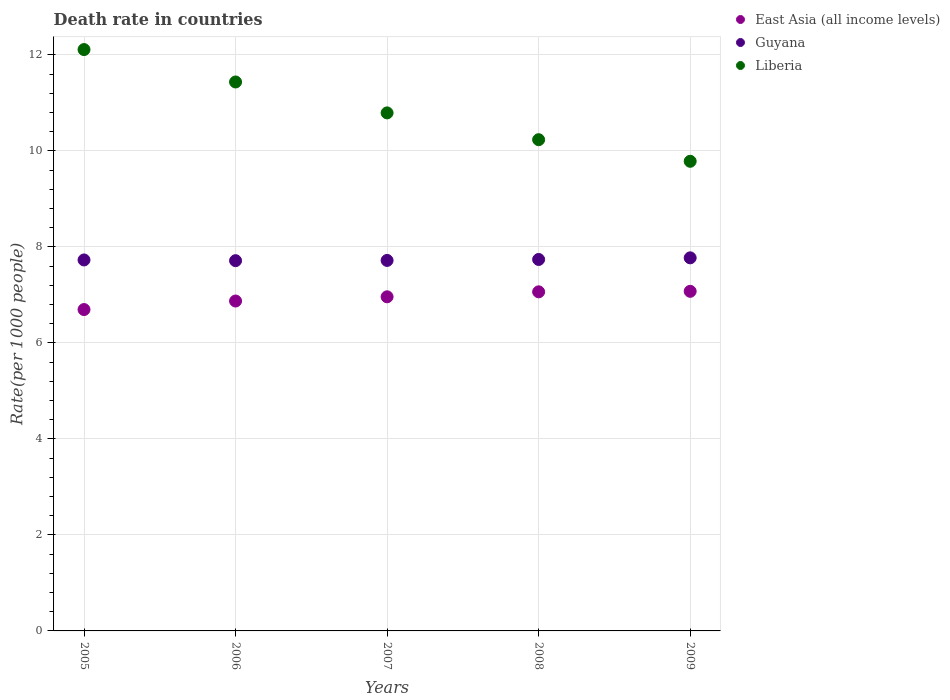How many different coloured dotlines are there?
Your answer should be very brief. 3. Is the number of dotlines equal to the number of legend labels?
Offer a very short reply. Yes. What is the death rate in Guyana in 2007?
Your response must be concise. 7.72. Across all years, what is the maximum death rate in Guyana?
Offer a terse response. 7.77. Across all years, what is the minimum death rate in Guyana?
Keep it short and to the point. 7.71. In which year was the death rate in Liberia maximum?
Offer a terse response. 2005. In which year was the death rate in Liberia minimum?
Your answer should be compact. 2009. What is the total death rate in East Asia (all income levels) in the graph?
Offer a very short reply. 34.66. What is the difference between the death rate in East Asia (all income levels) in 2006 and that in 2009?
Ensure brevity in your answer.  -0.2. What is the difference between the death rate in Liberia in 2007 and the death rate in East Asia (all income levels) in 2009?
Your answer should be very brief. 3.72. What is the average death rate in East Asia (all income levels) per year?
Your answer should be very brief. 6.93. In the year 2005, what is the difference between the death rate in Liberia and death rate in East Asia (all income levels)?
Provide a short and direct response. 5.42. In how many years, is the death rate in Guyana greater than 8?
Make the answer very short. 0. What is the ratio of the death rate in Liberia in 2007 to that in 2008?
Provide a succinct answer. 1.05. Is the difference between the death rate in Liberia in 2007 and 2008 greater than the difference between the death rate in East Asia (all income levels) in 2007 and 2008?
Your answer should be very brief. Yes. What is the difference between the highest and the second highest death rate in Liberia?
Your answer should be very brief. 0.68. What is the difference between the highest and the lowest death rate in East Asia (all income levels)?
Your response must be concise. 0.38. Is the death rate in Liberia strictly greater than the death rate in East Asia (all income levels) over the years?
Your response must be concise. Yes. How many years are there in the graph?
Make the answer very short. 5. Does the graph contain grids?
Your answer should be very brief. Yes. Where does the legend appear in the graph?
Offer a very short reply. Top right. How are the legend labels stacked?
Make the answer very short. Vertical. What is the title of the graph?
Provide a short and direct response. Death rate in countries. What is the label or title of the X-axis?
Your answer should be very brief. Years. What is the label or title of the Y-axis?
Your answer should be very brief. Rate(per 1000 people). What is the Rate(per 1000 people) in East Asia (all income levels) in 2005?
Provide a short and direct response. 6.69. What is the Rate(per 1000 people) in Guyana in 2005?
Your answer should be very brief. 7.73. What is the Rate(per 1000 people) of Liberia in 2005?
Make the answer very short. 12.11. What is the Rate(per 1000 people) of East Asia (all income levels) in 2006?
Offer a very short reply. 6.87. What is the Rate(per 1000 people) in Guyana in 2006?
Your answer should be very brief. 7.71. What is the Rate(per 1000 people) in Liberia in 2006?
Make the answer very short. 11.43. What is the Rate(per 1000 people) in East Asia (all income levels) in 2007?
Keep it short and to the point. 6.96. What is the Rate(per 1000 people) in Guyana in 2007?
Keep it short and to the point. 7.72. What is the Rate(per 1000 people) of Liberia in 2007?
Ensure brevity in your answer.  10.79. What is the Rate(per 1000 people) of East Asia (all income levels) in 2008?
Make the answer very short. 7.06. What is the Rate(per 1000 people) of Guyana in 2008?
Ensure brevity in your answer.  7.74. What is the Rate(per 1000 people) of Liberia in 2008?
Provide a short and direct response. 10.23. What is the Rate(per 1000 people) of East Asia (all income levels) in 2009?
Give a very brief answer. 7.07. What is the Rate(per 1000 people) of Guyana in 2009?
Your response must be concise. 7.77. What is the Rate(per 1000 people) in Liberia in 2009?
Provide a succinct answer. 9.78. Across all years, what is the maximum Rate(per 1000 people) in East Asia (all income levels)?
Give a very brief answer. 7.07. Across all years, what is the maximum Rate(per 1000 people) of Guyana?
Your response must be concise. 7.77. Across all years, what is the maximum Rate(per 1000 people) of Liberia?
Ensure brevity in your answer.  12.11. Across all years, what is the minimum Rate(per 1000 people) in East Asia (all income levels)?
Ensure brevity in your answer.  6.69. Across all years, what is the minimum Rate(per 1000 people) of Guyana?
Provide a short and direct response. 7.71. Across all years, what is the minimum Rate(per 1000 people) of Liberia?
Your response must be concise. 9.78. What is the total Rate(per 1000 people) of East Asia (all income levels) in the graph?
Provide a short and direct response. 34.66. What is the total Rate(per 1000 people) of Guyana in the graph?
Ensure brevity in your answer.  38.66. What is the total Rate(per 1000 people) in Liberia in the graph?
Give a very brief answer. 54.35. What is the difference between the Rate(per 1000 people) in East Asia (all income levels) in 2005 and that in 2006?
Ensure brevity in your answer.  -0.18. What is the difference between the Rate(per 1000 people) of Guyana in 2005 and that in 2006?
Ensure brevity in your answer.  0.01. What is the difference between the Rate(per 1000 people) in Liberia in 2005 and that in 2006?
Keep it short and to the point. 0.68. What is the difference between the Rate(per 1000 people) of East Asia (all income levels) in 2005 and that in 2007?
Provide a succinct answer. -0.27. What is the difference between the Rate(per 1000 people) in Guyana in 2005 and that in 2007?
Your answer should be very brief. 0.01. What is the difference between the Rate(per 1000 people) in Liberia in 2005 and that in 2007?
Give a very brief answer. 1.32. What is the difference between the Rate(per 1000 people) in East Asia (all income levels) in 2005 and that in 2008?
Make the answer very short. -0.37. What is the difference between the Rate(per 1000 people) in Guyana in 2005 and that in 2008?
Make the answer very short. -0.01. What is the difference between the Rate(per 1000 people) of Liberia in 2005 and that in 2008?
Give a very brief answer. 1.88. What is the difference between the Rate(per 1000 people) in East Asia (all income levels) in 2005 and that in 2009?
Give a very brief answer. -0.38. What is the difference between the Rate(per 1000 people) of Guyana in 2005 and that in 2009?
Offer a very short reply. -0.04. What is the difference between the Rate(per 1000 people) in Liberia in 2005 and that in 2009?
Offer a very short reply. 2.33. What is the difference between the Rate(per 1000 people) of East Asia (all income levels) in 2006 and that in 2007?
Provide a succinct answer. -0.09. What is the difference between the Rate(per 1000 people) in Guyana in 2006 and that in 2007?
Make the answer very short. -0.01. What is the difference between the Rate(per 1000 people) in Liberia in 2006 and that in 2007?
Ensure brevity in your answer.  0.64. What is the difference between the Rate(per 1000 people) of East Asia (all income levels) in 2006 and that in 2008?
Your answer should be very brief. -0.19. What is the difference between the Rate(per 1000 people) in Guyana in 2006 and that in 2008?
Keep it short and to the point. -0.03. What is the difference between the Rate(per 1000 people) in Liberia in 2006 and that in 2008?
Ensure brevity in your answer.  1.2. What is the difference between the Rate(per 1000 people) in East Asia (all income levels) in 2006 and that in 2009?
Offer a very short reply. -0.2. What is the difference between the Rate(per 1000 people) in Guyana in 2006 and that in 2009?
Provide a succinct answer. -0.06. What is the difference between the Rate(per 1000 people) of Liberia in 2006 and that in 2009?
Your response must be concise. 1.65. What is the difference between the Rate(per 1000 people) of East Asia (all income levels) in 2007 and that in 2008?
Your response must be concise. -0.1. What is the difference between the Rate(per 1000 people) in Guyana in 2007 and that in 2008?
Make the answer very short. -0.02. What is the difference between the Rate(per 1000 people) of Liberia in 2007 and that in 2008?
Your answer should be compact. 0.56. What is the difference between the Rate(per 1000 people) of East Asia (all income levels) in 2007 and that in 2009?
Offer a terse response. -0.11. What is the difference between the Rate(per 1000 people) in Guyana in 2007 and that in 2009?
Your answer should be very brief. -0.05. What is the difference between the Rate(per 1000 people) in Liberia in 2007 and that in 2009?
Keep it short and to the point. 1.01. What is the difference between the Rate(per 1000 people) in East Asia (all income levels) in 2008 and that in 2009?
Make the answer very short. -0.01. What is the difference between the Rate(per 1000 people) in Guyana in 2008 and that in 2009?
Offer a very short reply. -0.03. What is the difference between the Rate(per 1000 people) in Liberia in 2008 and that in 2009?
Provide a succinct answer. 0.45. What is the difference between the Rate(per 1000 people) of East Asia (all income levels) in 2005 and the Rate(per 1000 people) of Guyana in 2006?
Give a very brief answer. -1.02. What is the difference between the Rate(per 1000 people) of East Asia (all income levels) in 2005 and the Rate(per 1000 people) of Liberia in 2006?
Ensure brevity in your answer.  -4.74. What is the difference between the Rate(per 1000 people) of Guyana in 2005 and the Rate(per 1000 people) of Liberia in 2006?
Keep it short and to the point. -3.71. What is the difference between the Rate(per 1000 people) of East Asia (all income levels) in 2005 and the Rate(per 1000 people) of Guyana in 2007?
Keep it short and to the point. -1.02. What is the difference between the Rate(per 1000 people) of East Asia (all income levels) in 2005 and the Rate(per 1000 people) of Liberia in 2007?
Provide a succinct answer. -4.1. What is the difference between the Rate(per 1000 people) of Guyana in 2005 and the Rate(per 1000 people) of Liberia in 2007?
Ensure brevity in your answer.  -3.06. What is the difference between the Rate(per 1000 people) in East Asia (all income levels) in 2005 and the Rate(per 1000 people) in Guyana in 2008?
Give a very brief answer. -1.04. What is the difference between the Rate(per 1000 people) in East Asia (all income levels) in 2005 and the Rate(per 1000 people) in Liberia in 2008?
Offer a very short reply. -3.54. What is the difference between the Rate(per 1000 people) in Guyana in 2005 and the Rate(per 1000 people) in Liberia in 2008?
Make the answer very short. -2.5. What is the difference between the Rate(per 1000 people) in East Asia (all income levels) in 2005 and the Rate(per 1000 people) in Guyana in 2009?
Your answer should be very brief. -1.08. What is the difference between the Rate(per 1000 people) in East Asia (all income levels) in 2005 and the Rate(per 1000 people) in Liberia in 2009?
Keep it short and to the point. -3.09. What is the difference between the Rate(per 1000 people) of Guyana in 2005 and the Rate(per 1000 people) of Liberia in 2009?
Keep it short and to the point. -2.06. What is the difference between the Rate(per 1000 people) of East Asia (all income levels) in 2006 and the Rate(per 1000 people) of Guyana in 2007?
Your answer should be compact. -0.85. What is the difference between the Rate(per 1000 people) of East Asia (all income levels) in 2006 and the Rate(per 1000 people) of Liberia in 2007?
Offer a very short reply. -3.92. What is the difference between the Rate(per 1000 people) in Guyana in 2006 and the Rate(per 1000 people) in Liberia in 2007?
Make the answer very short. -3.08. What is the difference between the Rate(per 1000 people) of East Asia (all income levels) in 2006 and the Rate(per 1000 people) of Guyana in 2008?
Make the answer very short. -0.87. What is the difference between the Rate(per 1000 people) in East Asia (all income levels) in 2006 and the Rate(per 1000 people) in Liberia in 2008?
Your response must be concise. -3.36. What is the difference between the Rate(per 1000 people) in Guyana in 2006 and the Rate(per 1000 people) in Liberia in 2008?
Keep it short and to the point. -2.52. What is the difference between the Rate(per 1000 people) of East Asia (all income levels) in 2006 and the Rate(per 1000 people) of Guyana in 2009?
Provide a succinct answer. -0.9. What is the difference between the Rate(per 1000 people) of East Asia (all income levels) in 2006 and the Rate(per 1000 people) of Liberia in 2009?
Make the answer very short. -2.91. What is the difference between the Rate(per 1000 people) in Guyana in 2006 and the Rate(per 1000 people) in Liberia in 2009?
Ensure brevity in your answer.  -2.07. What is the difference between the Rate(per 1000 people) of East Asia (all income levels) in 2007 and the Rate(per 1000 people) of Guyana in 2008?
Your answer should be very brief. -0.78. What is the difference between the Rate(per 1000 people) of East Asia (all income levels) in 2007 and the Rate(per 1000 people) of Liberia in 2008?
Provide a succinct answer. -3.27. What is the difference between the Rate(per 1000 people) in Guyana in 2007 and the Rate(per 1000 people) in Liberia in 2008?
Keep it short and to the point. -2.52. What is the difference between the Rate(per 1000 people) of East Asia (all income levels) in 2007 and the Rate(per 1000 people) of Guyana in 2009?
Provide a short and direct response. -0.81. What is the difference between the Rate(per 1000 people) of East Asia (all income levels) in 2007 and the Rate(per 1000 people) of Liberia in 2009?
Provide a succinct answer. -2.82. What is the difference between the Rate(per 1000 people) of Guyana in 2007 and the Rate(per 1000 people) of Liberia in 2009?
Offer a very short reply. -2.06. What is the difference between the Rate(per 1000 people) of East Asia (all income levels) in 2008 and the Rate(per 1000 people) of Guyana in 2009?
Your response must be concise. -0.71. What is the difference between the Rate(per 1000 people) of East Asia (all income levels) in 2008 and the Rate(per 1000 people) of Liberia in 2009?
Keep it short and to the point. -2.72. What is the difference between the Rate(per 1000 people) in Guyana in 2008 and the Rate(per 1000 people) in Liberia in 2009?
Your answer should be compact. -2.04. What is the average Rate(per 1000 people) of East Asia (all income levels) per year?
Your answer should be compact. 6.93. What is the average Rate(per 1000 people) in Guyana per year?
Provide a succinct answer. 7.73. What is the average Rate(per 1000 people) of Liberia per year?
Make the answer very short. 10.87. In the year 2005, what is the difference between the Rate(per 1000 people) in East Asia (all income levels) and Rate(per 1000 people) in Guyana?
Provide a succinct answer. -1.03. In the year 2005, what is the difference between the Rate(per 1000 people) of East Asia (all income levels) and Rate(per 1000 people) of Liberia?
Provide a short and direct response. -5.42. In the year 2005, what is the difference between the Rate(per 1000 people) in Guyana and Rate(per 1000 people) in Liberia?
Make the answer very short. -4.38. In the year 2006, what is the difference between the Rate(per 1000 people) in East Asia (all income levels) and Rate(per 1000 people) in Guyana?
Your answer should be compact. -0.84. In the year 2006, what is the difference between the Rate(per 1000 people) in East Asia (all income levels) and Rate(per 1000 people) in Liberia?
Provide a short and direct response. -4.56. In the year 2006, what is the difference between the Rate(per 1000 people) of Guyana and Rate(per 1000 people) of Liberia?
Ensure brevity in your answer.  -3.72. In the year 2007, what is the difference between the Rate(per 1000 people) of East Asia (all income levels) and Rate(per 1000 people) of Guyana?
Offer a terse response. -0.76. In the year 2007, what is the difference between the Rate(per 1000 people) of East Asia (all income levels) and Rate(per 1000 people) of Liberia?
Ensure brevity in your answer.  -3.83. In the year 2007, what is the difference between the Rate(per 1000 people) of Guyana and Rate(per 1000 people) of Liberia?
Keep it short and to the point. -3.07. In the year 2008, what is the difference between the Rate(per 1000 people) in East Asia (all income levels) and Rate(per 1000 people) in Guyana?
Your response must be concise. -0.67. In the year 2008, what is the difference between the Rate(per 1000 people) in East Asia (all income levels) and Rate(per 1000 people) in Liberia?
Provide a succinct answer. -3.17. In the year 2008, what is the difference between the Rate(per 1000 people) of Guyana and Rate(per 1000 people) of Liberia?
Make the answer very short. -2.5. In the year 2009, what is the difference between the Rate(per 1000 people) in East Asia (all income levels) and Rate(per 1000 people) in Guyana?
Your answer should be compact. -0.7. In the year 2009, what is the difference between the Rate(per 1000 people) of East Asia (all income levels) and Rate(per 1000 people) of Liberia?
Your answer should be compact. -2.71. In the year 2009, what is the difference between the Rate(per 1000 people) of Guyana and Rate(per 1000 people) of Liberia?
Your answer should be compact. -2.01. What is the ratio of the Rate(per 1000 people) of East Asia (all income levels) in 2005 to that in 2006?
Offer a terse response. 0.97. What is the ratio of the Rate(per 1000 people) of Liberia in 2005 to that in 2006?
Ensure brevity in your answer.  1.06. What is the ratio of the Rate(per 1000 people) in East Asia (all income levels) in 2005 to that in 2007?
Make the answer very short. 0.96. What is the ratio of the Rate(per 1000 people) in Guyana in 2005 to that in 2007?
Your answer should be compact. 1. What is the ratio of the Rate(per 1000 people) in Liberia in 2005 to that in 2007?
Ensure brevity in your answer.  1.12. What is the ratio of the Rate(per 1000 people) of East Asia (all income levels) in 2005 to that in 2008?
Give a very brief answer. 0.95. What is the ratio of the Rate(per 1000 people) of Guyana in 2005 to that in 2008?
Keep it short and to the point. 1. What is the ratio of the Rate(per 1000 people) of Liberia in 2005 to that in 2008?
Give a very brief answer. 1.18. What is the ratio of the Rate(per 1000 people) of East Asia (all income levels) in 2005 to that in 2009?
Offer a very short reply. 0.95. What is the ratio of the Rate(per 1000 people) in Guyana in 2005 to that in 2009?
Provide a short and direct response. 0.99. What is the ratio of the Rate(per 1000 people) of Liberia in 2005 to that in 2009?
Your answer should be very brief. 1.24. What is the ratio of the Rate(per 1000 people) in East Asia (all income levels) in 2006 to that in 2007?
Keep it short and to the point. 0.99. What is the ratio of the Rate(per 1000 people) of Guyana in 2006 to that in 2007?
Offer a very short reply. 1. What is the ratio of the Rate(per 1000 people) of Liberia in 2006 to that in 2007?
Offer a very short reply. 1.06. What is the ratio of the Rate(per 1000 people) of East Asia (all income levels) in 2006 to that in 2008?
Ensure brevity in your answer.  0.97. What is the ratio of the Rate(per 1000 people) in Guyana in 2006 to that in 2008?
Provide a succinct answer. 1. What is the ratio of the Rate(per 1000 people) of Liberia in 2006 to that in 2008?
Make the answer very short. 1.12. What is the ratio of the Rate(per 1000 people) of East Asia (all income levels) in 2006 to that in 2009?
Give a very brief answer. 0.97. What is the ratio of the Rate(per 1000 people) of Liberia in 2006 to that in 2009?
Your response must be concise. 1.17. What is the ratio of the Rate(per 1000 people) in Liberia in 2007 to that in 2008?
Your answer should be very brief. 1.05. What is the ratio of the Rate(per 1000 people) of East Asia (all income levels) in 2007 to that in 2009?
Make the answer very short. 0.98. What is the ratio of the Rate(per 1000 people) of Guyana in 2007 to that in 2009?
Make the answer very short. 0.99. What is the ratio of the Rate(per 1000 people) of Liberia in 2007 to that in 2009?
Your answer should be very brief. 1.1. What is the ratio of the Rate(per 1000 people) of East Asia (all income levels) in 2008 to that in 2009?
Make the answer very short. 1. What is the ratio of the Rate(per 1000 people) of Guyana in 2008 to that in 2009?
Ensure brevity in your answer.  1. What is the ratio of the Rate(per 1000 people) in Liberia in 2008 to that in 2009?
Keep it short and to the point. 1.05. What is the difference between the highest and the second highest Rate(per 1000 people) in East Asia (all income levels)?
Make the answer very short. 0.01. What is the difference between the highest and the second highest Rate(per 1000 people) in Guyana?
Ensure brevity in your answer.  0.03. What is the difference between the highest and the second highest Rate(per 1000 people) in Liberia?
Provide a succinct answer. 0.68. What is the difference between the highest and the lowest Rate(per 1000 people) in East Asia (all income levels)?
Your answer should be compact. 0.38. What is the difference between the highest and the lowest Rate(per 1000 people) of Guyana?
Give a very brief answer. 0.06. What is the difference between the highest and the lowest Rate(per 1000 people) in Liberia?
Give a very brief answer. 2.33. 